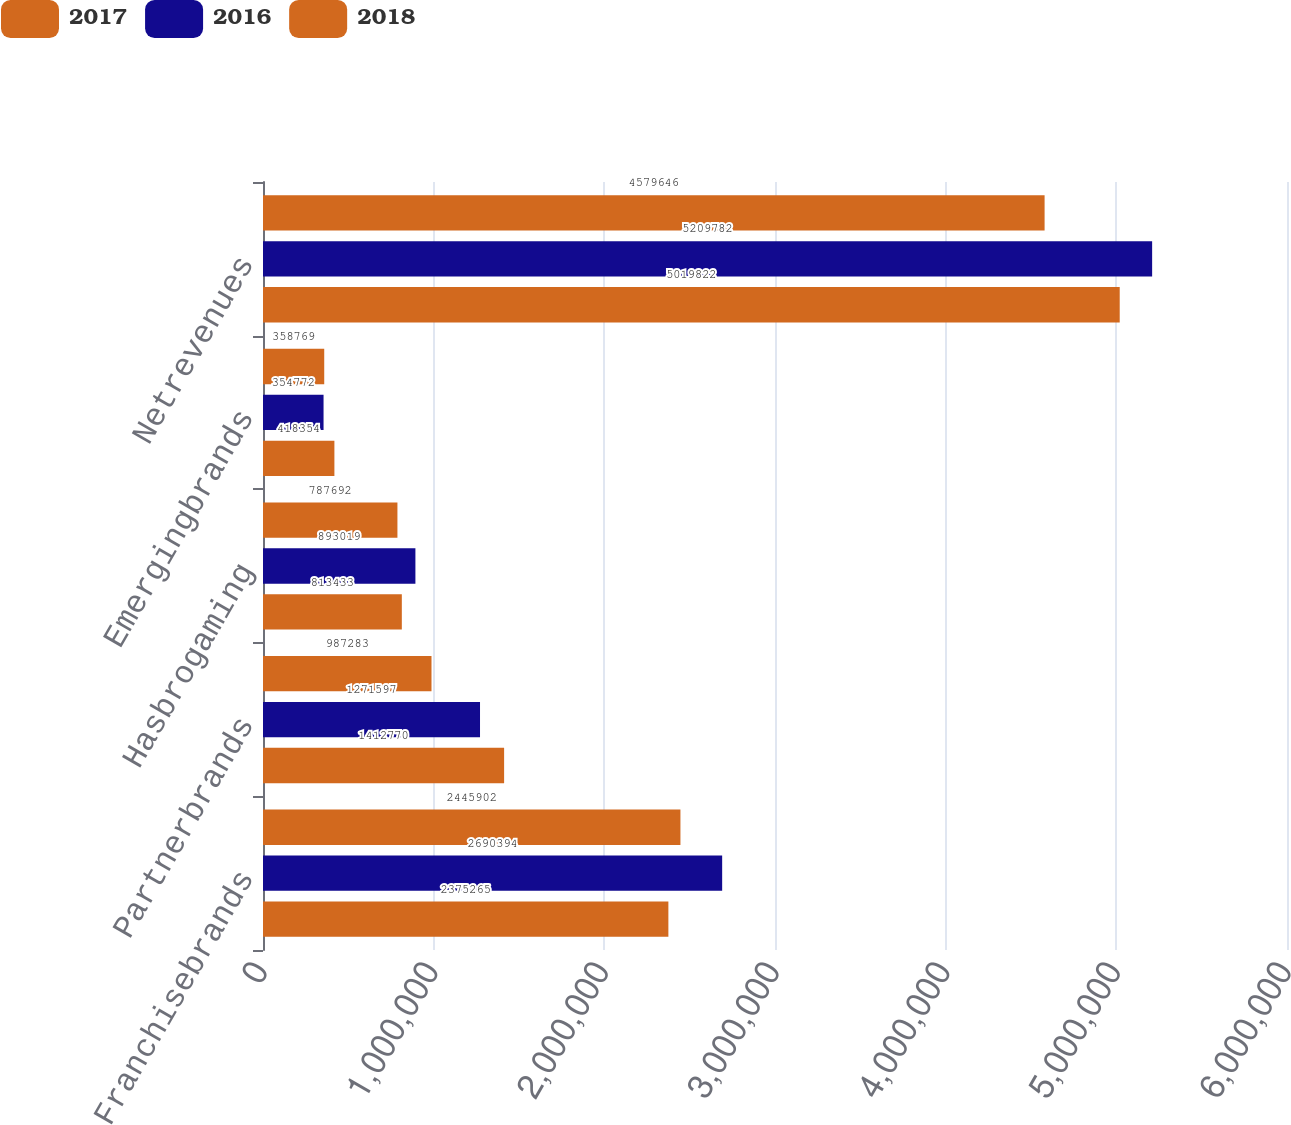Convert chart. <chart><loc_0><loc_0><loc_500><loc_500><stacked_bar_chart><ecel><fcel>Franchisebrands<fcel>Partnerbrands<fcel>Hasbrogaming<fcel>Emergingbrands<fcel>Netrevenues<nl><fcel>2017<fcel>2.4459e+06<fcel>987283<fcel>787692<fcel>358769<fcel>4.57965e+06<nl><fcel>2016<fcel>2.69039e+06<fcel>1.2716e+06<fcel>893019<fcel>354772<fcel>5.20978e+06<nl><fcel>2018<fcel>2.37526e+06<fcel>1.41277e+06<fcel>813433<fcel>418354<fcel>5.01982e+06<nl></chart> 